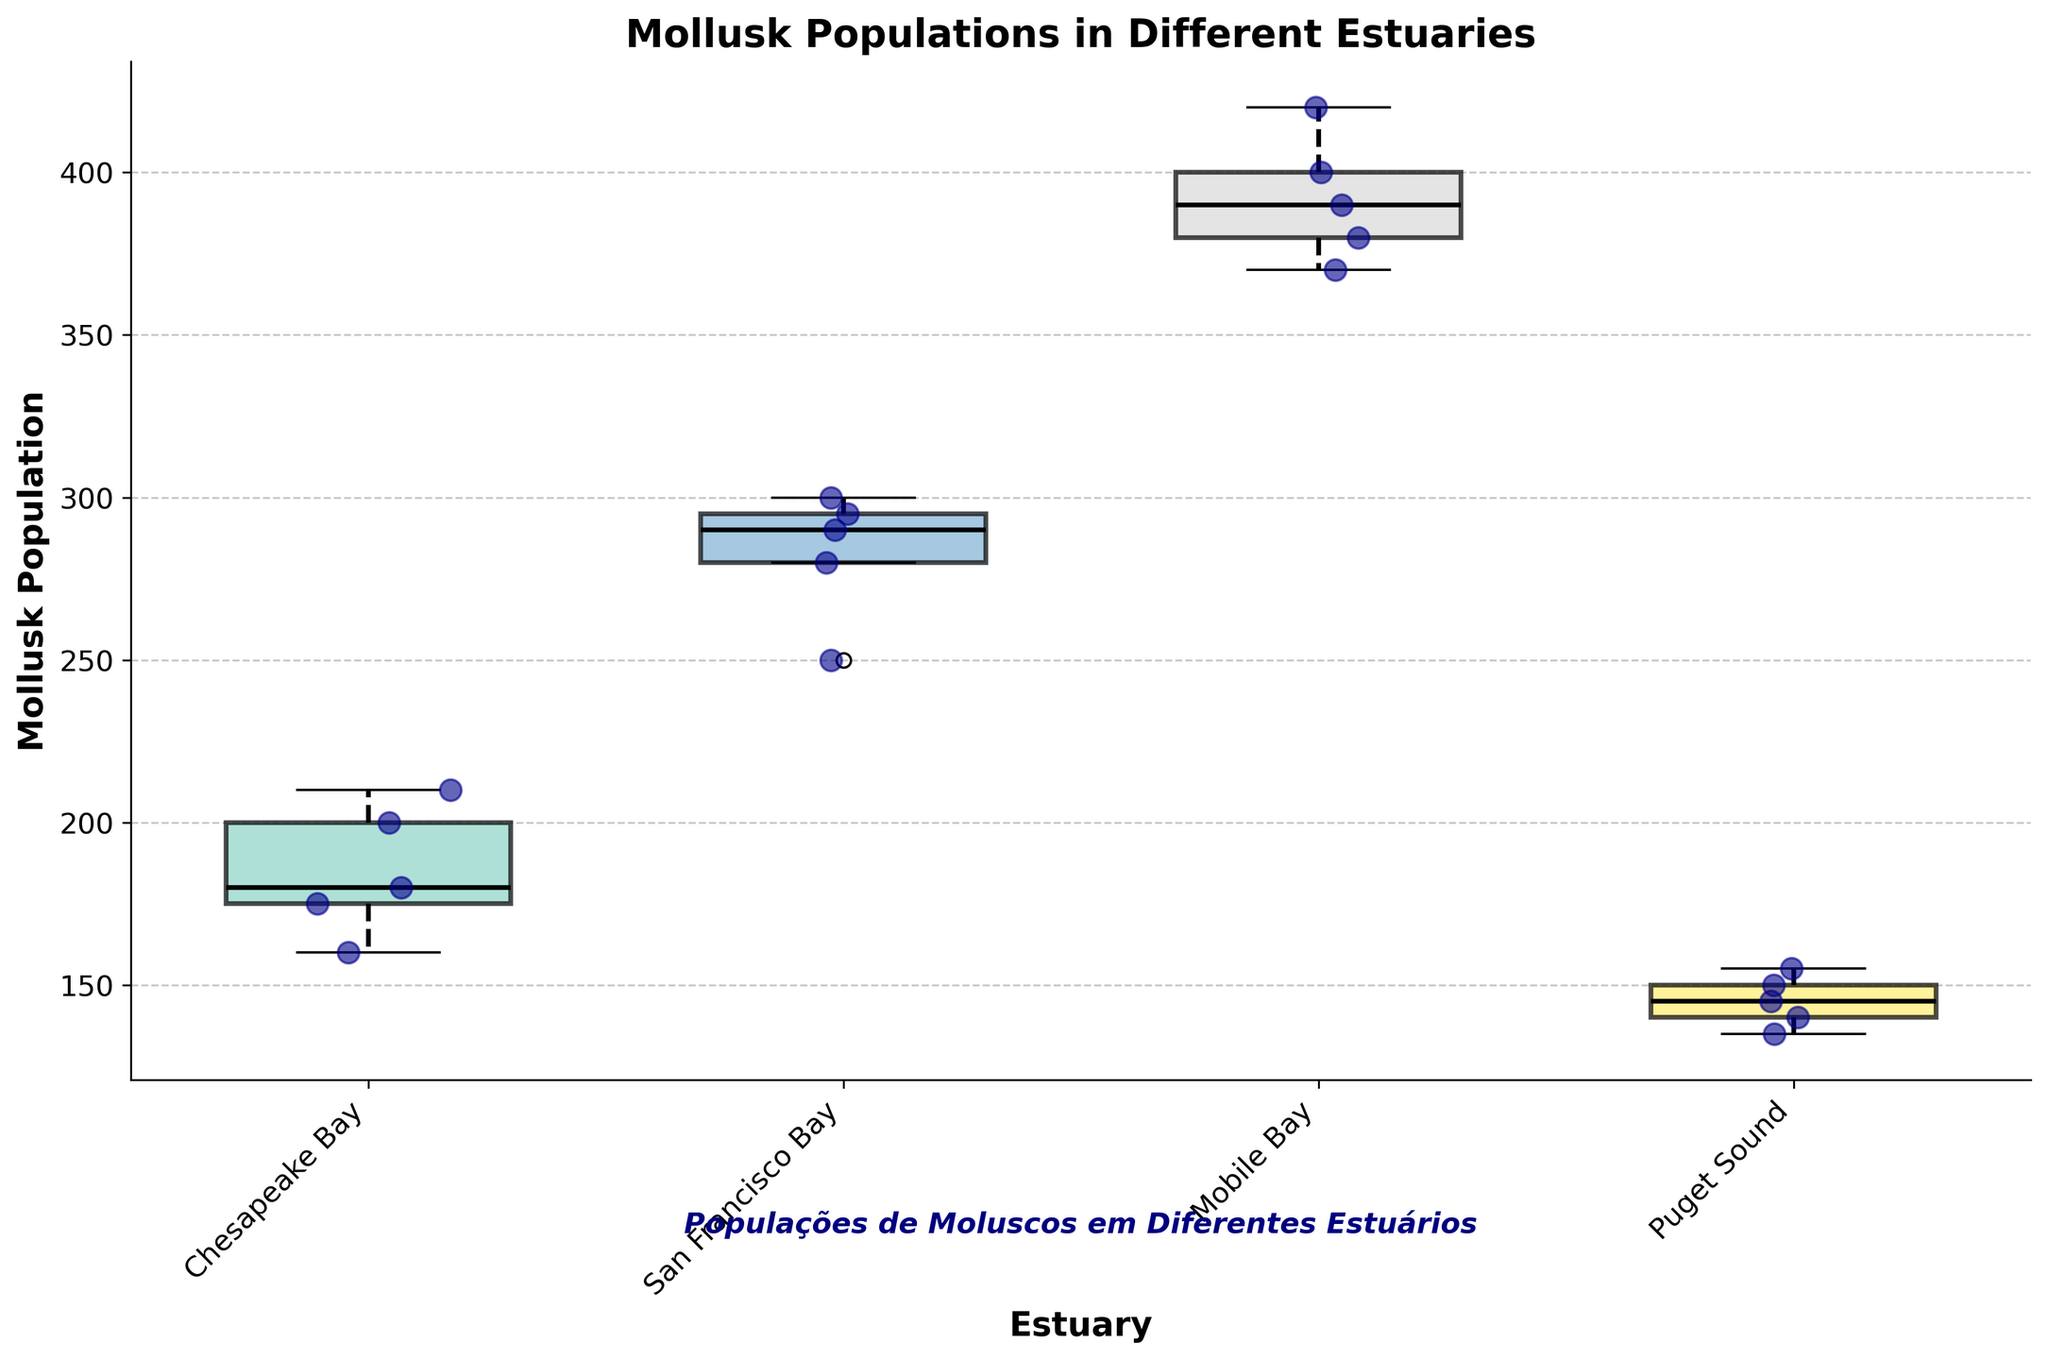What is the title of the figure? The title of the figure is located at the top-center of the plot in bold font.
Answer: Mollusk Populations in Different Estuaries How many estuaries are represented in the figure? Count the number of distinct labels on the x-axis of the plot.
Answer: Four Which estuary has the highest median mollusk population? Look at the central line inside each box plot, and identify which box has the highest position for this line.
Answer: Mobile Bay Which estuary shows the lowest variability in mollusk population? Examine the length of the box and the whiskers in each box plot. The estuary with the shortest box and whiskers combined indicates the lowest variability.
Answer: Puget Sound What is the range of mollusk populations in Puget Sound? Determine the lowest and highest points in the box plot for Puget Sound. The range is the difference between these two points.
Answer: 135-155 How does the mollusk population in Chesapeake Bay compare to San Francisco Bay? Compare the positions of the boxes, medians, whiskers, and scatter points for Chesapeake Bay and San Francisco Bay. Assess which estuary seems to have a higher and more varied population.
Answer: Chesapeake Bay has a generally lower population and less variability compared to San Francisco Bay What is the interquartile range (IQR) for the mollusk population in Mobile Bay? Calculate the difference between the upper quartile (top of the box) and the lower quartile (bottom of the box) in Mobile Bay’s box plot.
Answer: Approximately 390 - 370 What does the scatter within each estuary's box represent? Examine the scattering of points within each box plot; note that they represent individual data points beyond the summary statistics of the box plot.
Answer: Individual mollusk population measurements Which estuary appears to have outliers, and what are they? Identify if any points lie outside the whiskers for each box plot. The estuary with such points has outliers.
Answer: Chesapeake Bay with data points at 200 and 210 What is the Portuguese translation provided at the bottom of the figure? Locate the text box added beneath the plot.
Answer: Populações de Moluscos em Diferentes Estuários 